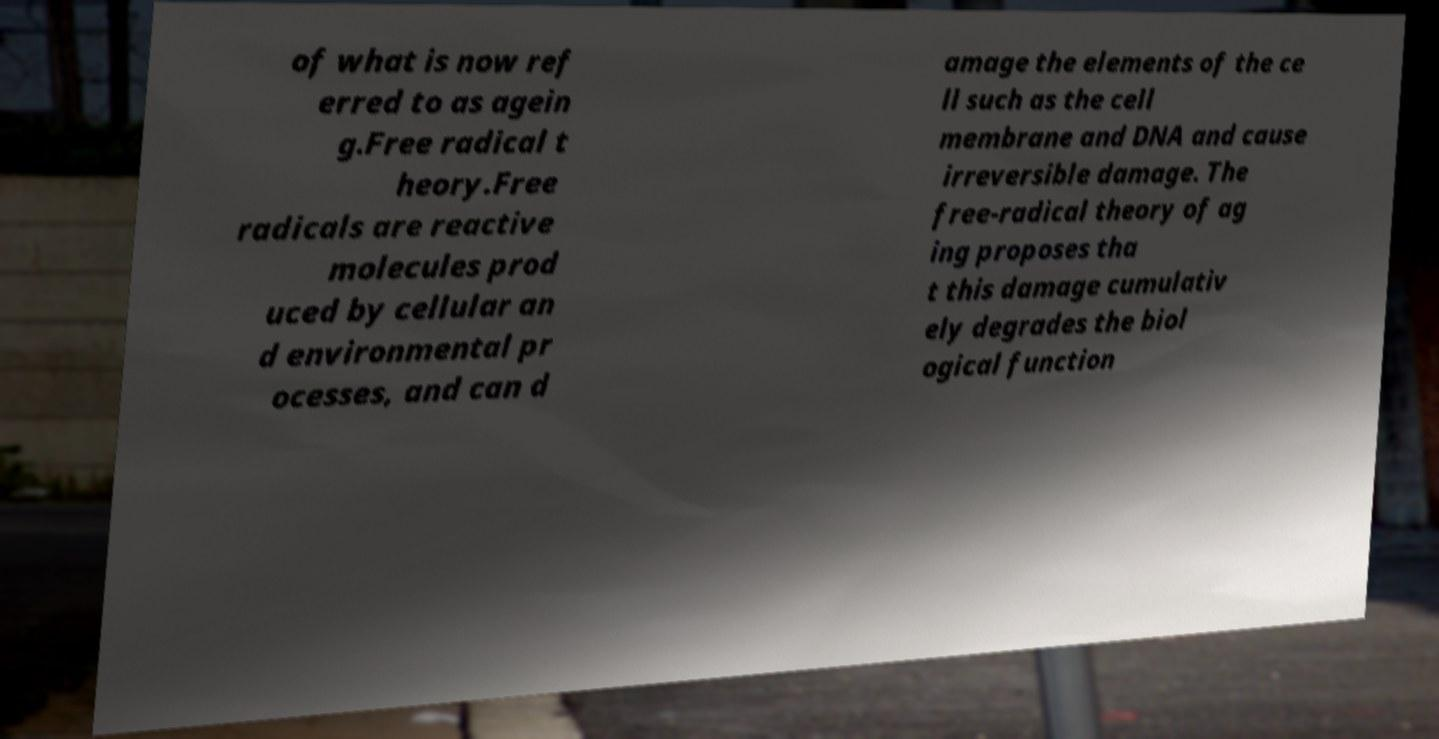Can you read and provide the text displayed in the image?This photo seems to have some interesting text. Can you extract and type it out for me? of what is now ref erred to as agein g.Free radical t heory.Free radicals are reactive molecules prod uced by cellular an d environmental pr ocesses, and can d amage the elements of the ce ll such as the cell membrane and DNA and cause irreversible damage. The free-radical theory of ag ing proposes tha t this damage cumulativ ely degrades the biol ogical function 